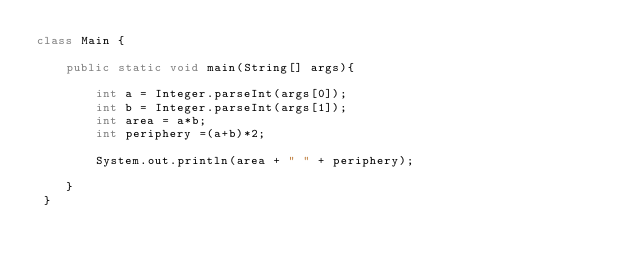Convert code to text. <code><loc_0><loc_0><loc_500><loc_500><_Java_>class Main {

	public static void main(String[] args){

		int a = Integer.parseInt(args[0]);
		int b = Integer.parseInt(args[1]);
		int area = a*b;
		int periphery =(a+b)*2;

		System.out.println(area + " " + periphery);

	}
 }</code> 